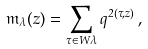Convert formula to latex. <formula><loc_0><loc_0><loc_500><loc_500>\mathfrak m _ { \lambda } ( z ) = \sum _ { \tau \in W \lambda } q ^ { 2 ( \tau , z ) } \, ,</formula> 